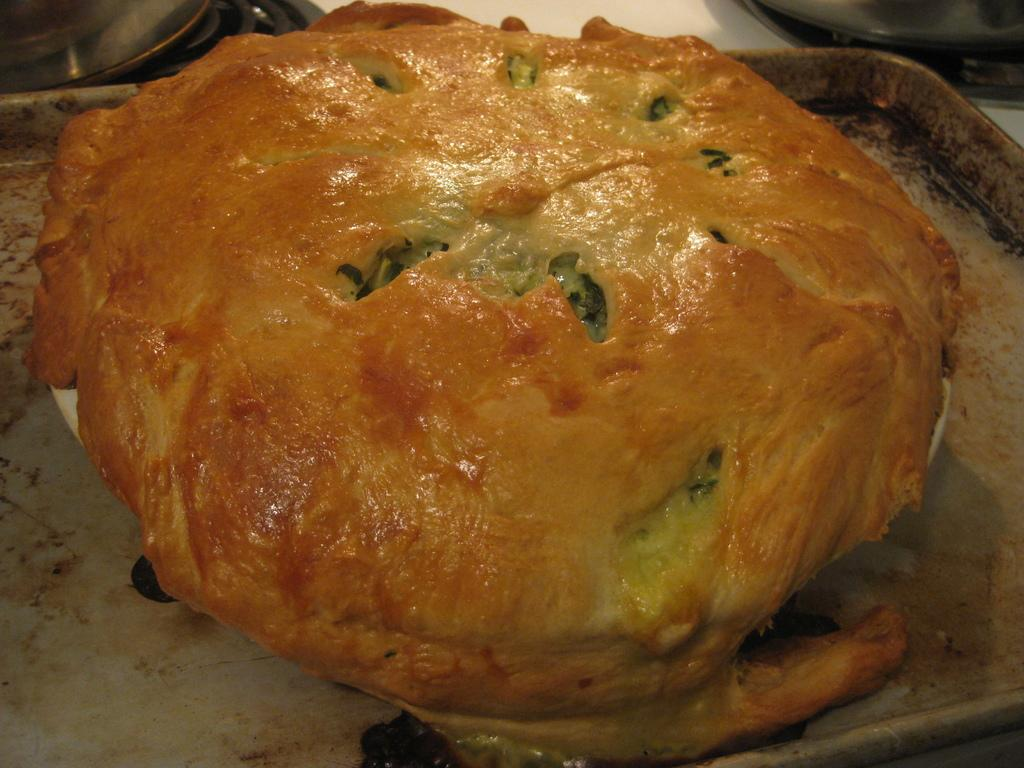What is located at the bottom of the image? There is a table at the bottom of the image. What can be found on the table? There is a food item, a tray, bowls, and plates on the table. How many types of tableware are present on the table? There are two types of tableware present on the table: bowls and plates. Can you see a giraffe eating cream in the image? No, there is no giraffe or cream present in the image. 